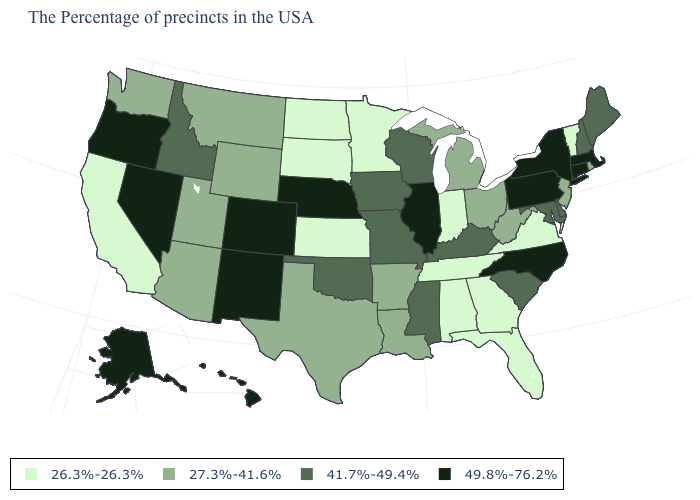Among the states that border Maine , which have the lowest value?
Give a very brief answer. New Hampshire. Does Nevada have the same value as Pennsylvania?
Short answer required. Yes. Among the states that border Colorado , does Nebraska have the highest value?
Short answer required. Yes. Is the legend a continuous bar?
Short answer required. No. What is the lowest value in the USA?
Quick response, please. 26.3%-26.3%. Does Alabama have the highest value in the USA?
Be succinct. No. What is the value of South Carolina?
Keep it brief. 41.7%-49.4%. Name the states that have a value in the range 49.8%-76.2%?
Write a very short answer. Massachusetts, Connecticut, New York, Pennsylvania, North Carolina, Illinois, Nebraska, Colorado, New Mexico, Nevada, Oregon, Alaska, Hawaii. What is the value of Arkansas?
Answer briefly. 27.3%-41.6%. Does the map have missing data?
Answer briefly. No. Does Illinois have the same value as Rhode Island?
Give a very brief answer. No. Does Alaska have a higher value than New Mexico?
Concise answer only. No. Does North Carolina have the lowest value in the South?
Write a very short answer. No. Among the states that border Kentucky , which have the highest value?
Answer briefly. Illinois. Name the states that have a value in the range 41.7%-49.4%?
Answer briefly. Maine, New Hampshire, Delaware, Maryland, South Carolina, Kentucky, Wisconsin, Mississippi, Missouri, Iowa, Oklahoma, Idaho. 